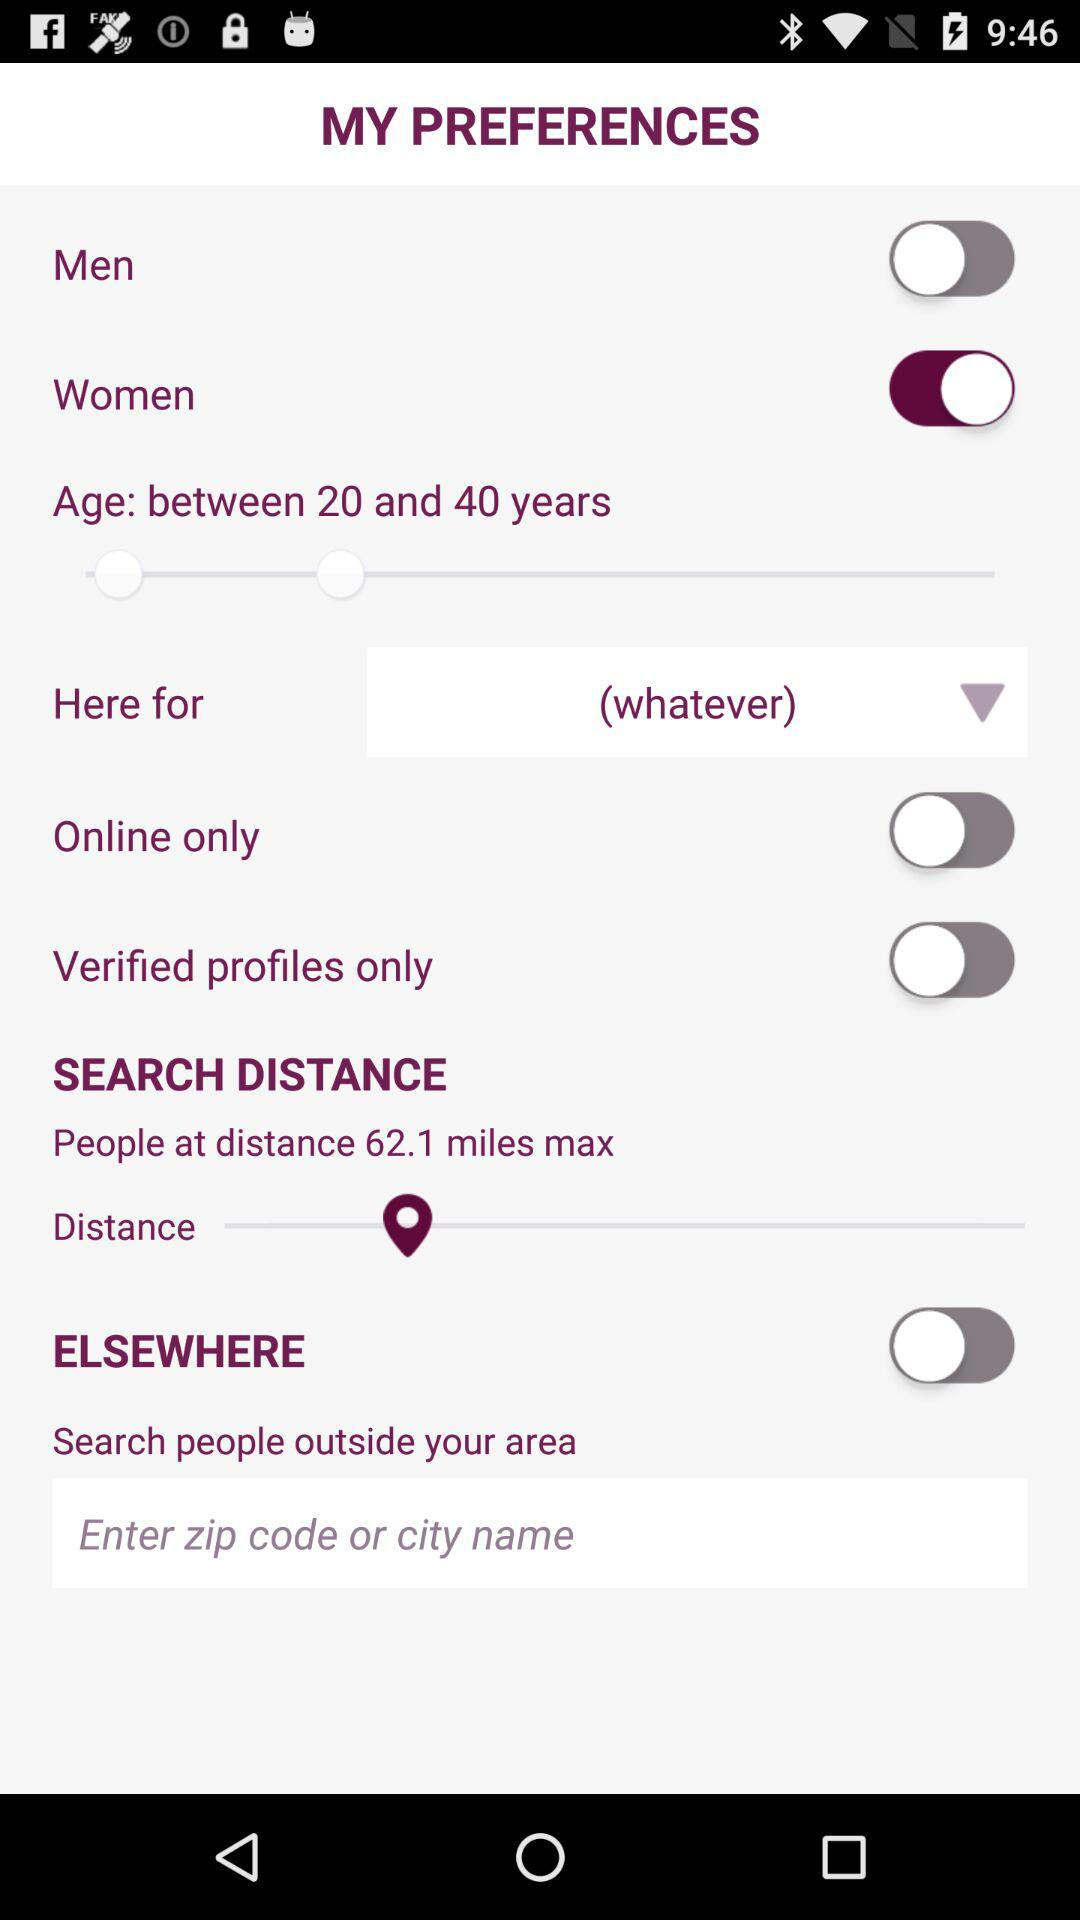What is the preference selected for gender? The selected preference is "Women". 